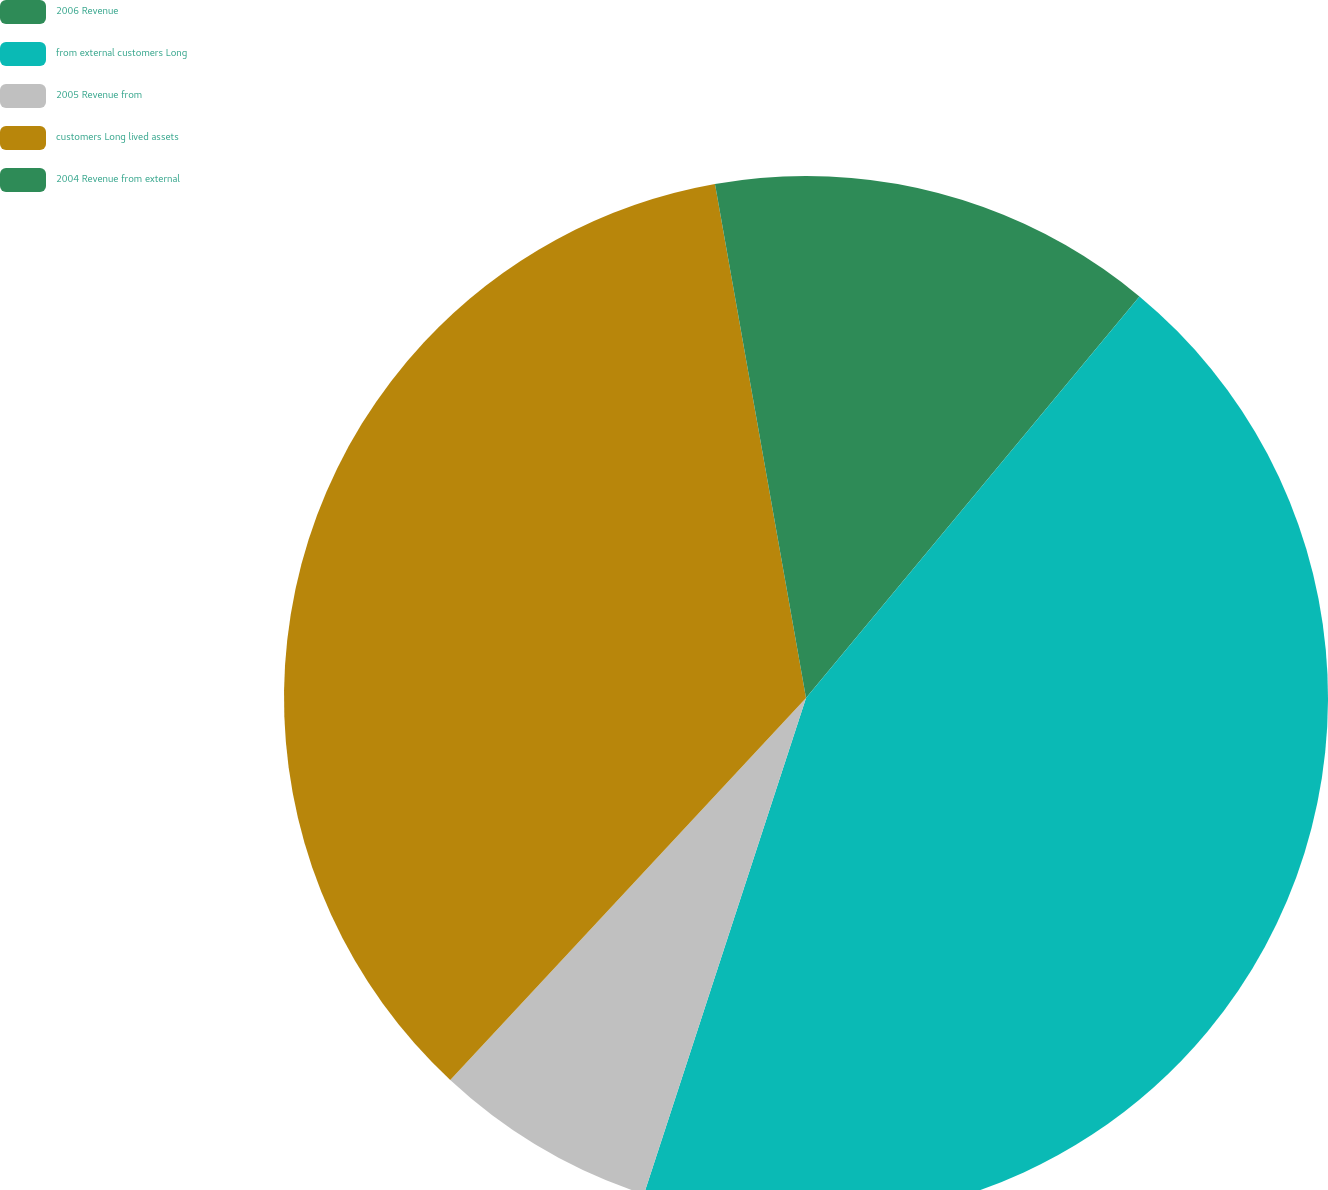<chart> <loc_0><loc_0><loc_500><loc_500><pie_chart><fcel>2006 Revenue<fcel>from external customers Long<fcel>2005 Revenue from<fcel>customers Long lived assets<fcel>2004 Revenue from external<nl><fcel>11.03%<fcel>44.0%<fcel>6.91%<fcel>35.28%<fcel>2.79%<nl></chart> 